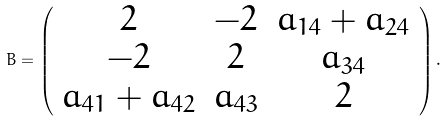Convert formula to latex. <formula><loc_0><loc_0><loc_500><loc_500>B = \left ( \begin{array} { c c c } 2 & - 2 & a _ { 1 4 } + a _ { 2 4 } \\ - 2 & 2 & a _ { 3 4 } \\ a _ { 4 1 } + a _ { 4 2 } & a _ { 4 3 } & 2 \\ \end{array} \right ) .</formula> 